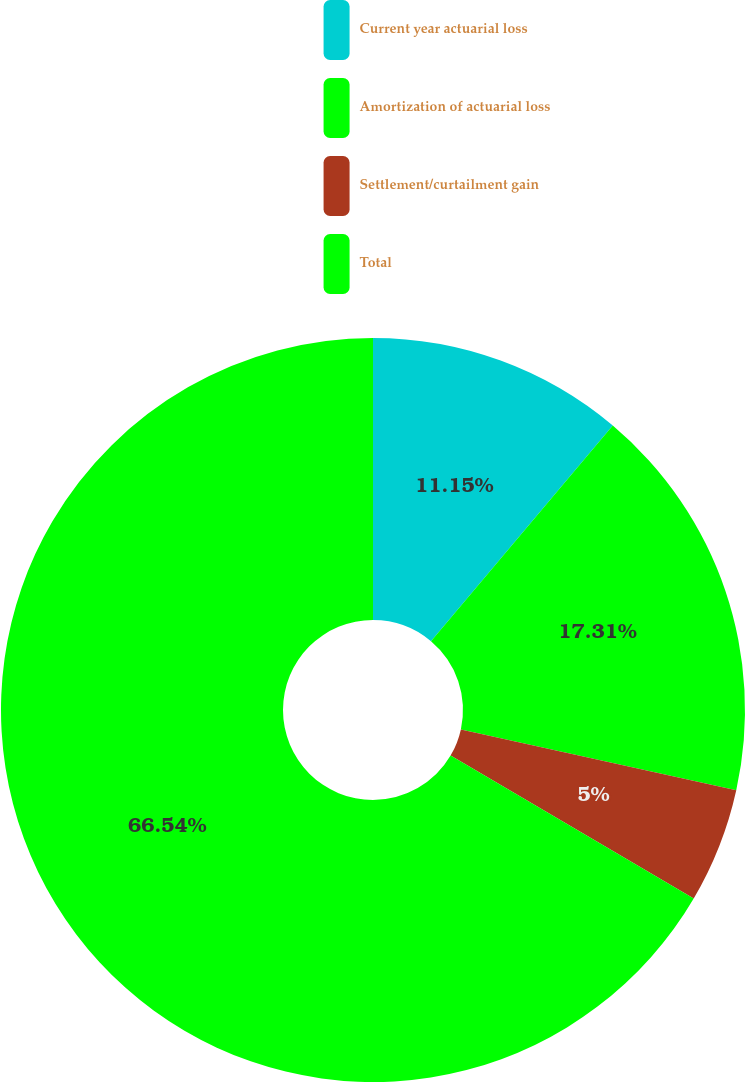Convert chart to OTSL. <chart><loc_0><loc_0><loc_500><loc_500><pie_chart><fcel>Current year actuarial loss<fcel>Amortization of actuarial loss<fcel>Settlement/curtailment gain<fcel>Total<nl><fcel>11.15%<fcel>17.31%<fcel>5.0%<fcel>66.55%<nl></chart> 